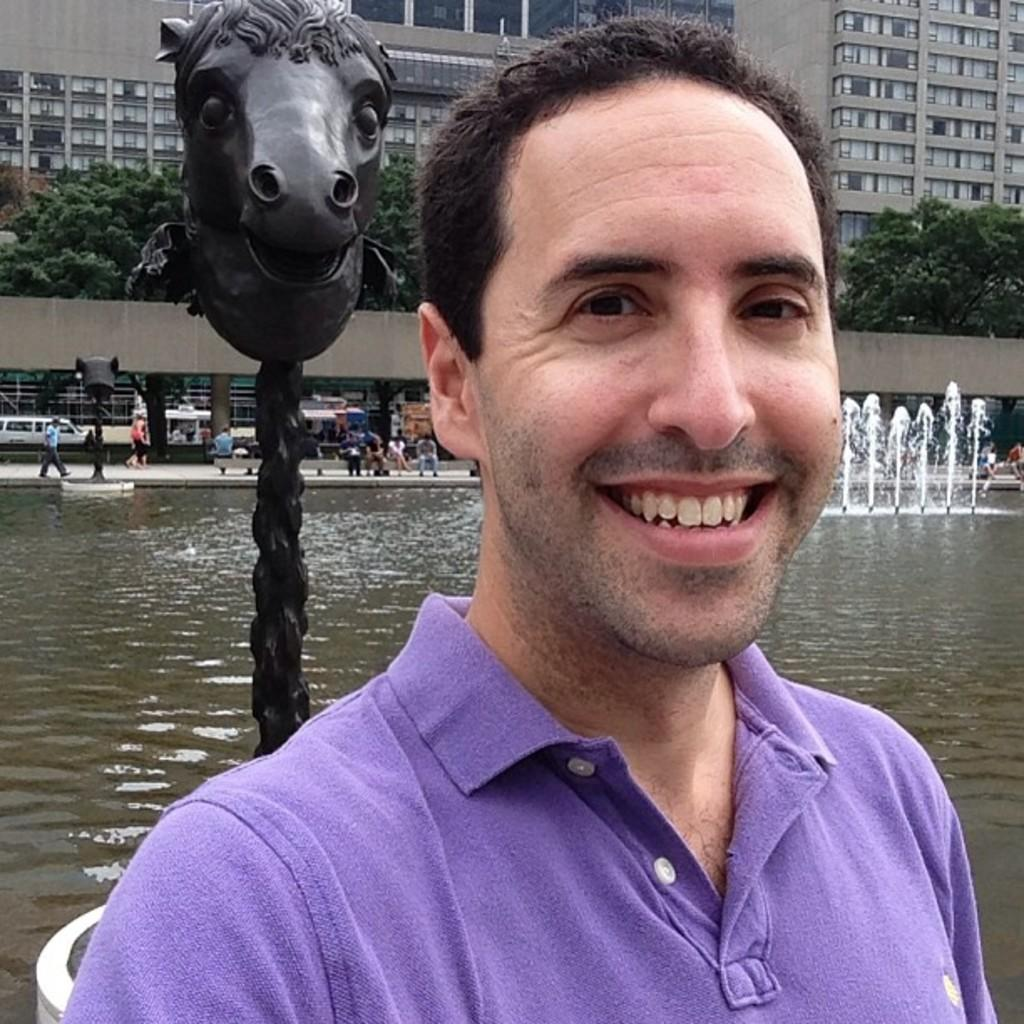What is the man in the image doing? The man in the image is smiling. What can be seen in the background of the image? There are buildings in the background of the image. What is the primary feature of the fountain in the image? The fountain in the image has water. How many people are present in the image? There are people in the image, but the exact number is not specified. What type of structure is the statue in the image? The statue is a standalone object in the image. What is the purpose of the poles in the image? The purpose of the poles in the image is not specified. What type of team is playing in the image? There is no team or any indication of a game being played in the image. How many toads can be seen in the image? There are no toads present in the image. 